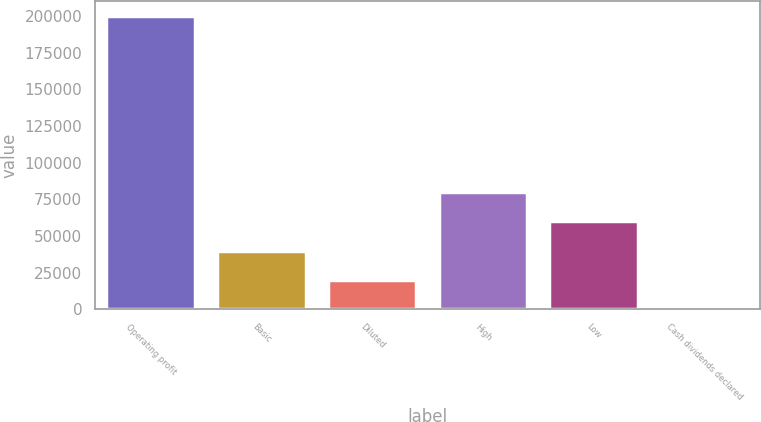Convert chart to OTSL. <chart><loc_0><loc_0><loc_500><loc_500><bar_chart><fcel>Operating profit<fcel>Basic<fcel>Diluted<fcel>High<fcel>Low<fcel>Cash dividends declared<nl><fcel>200155<fcel>40031.3<fcel>20015.8<fcel>80062.2<fcel>60046.7<fcel>0.36<nl></chart> 